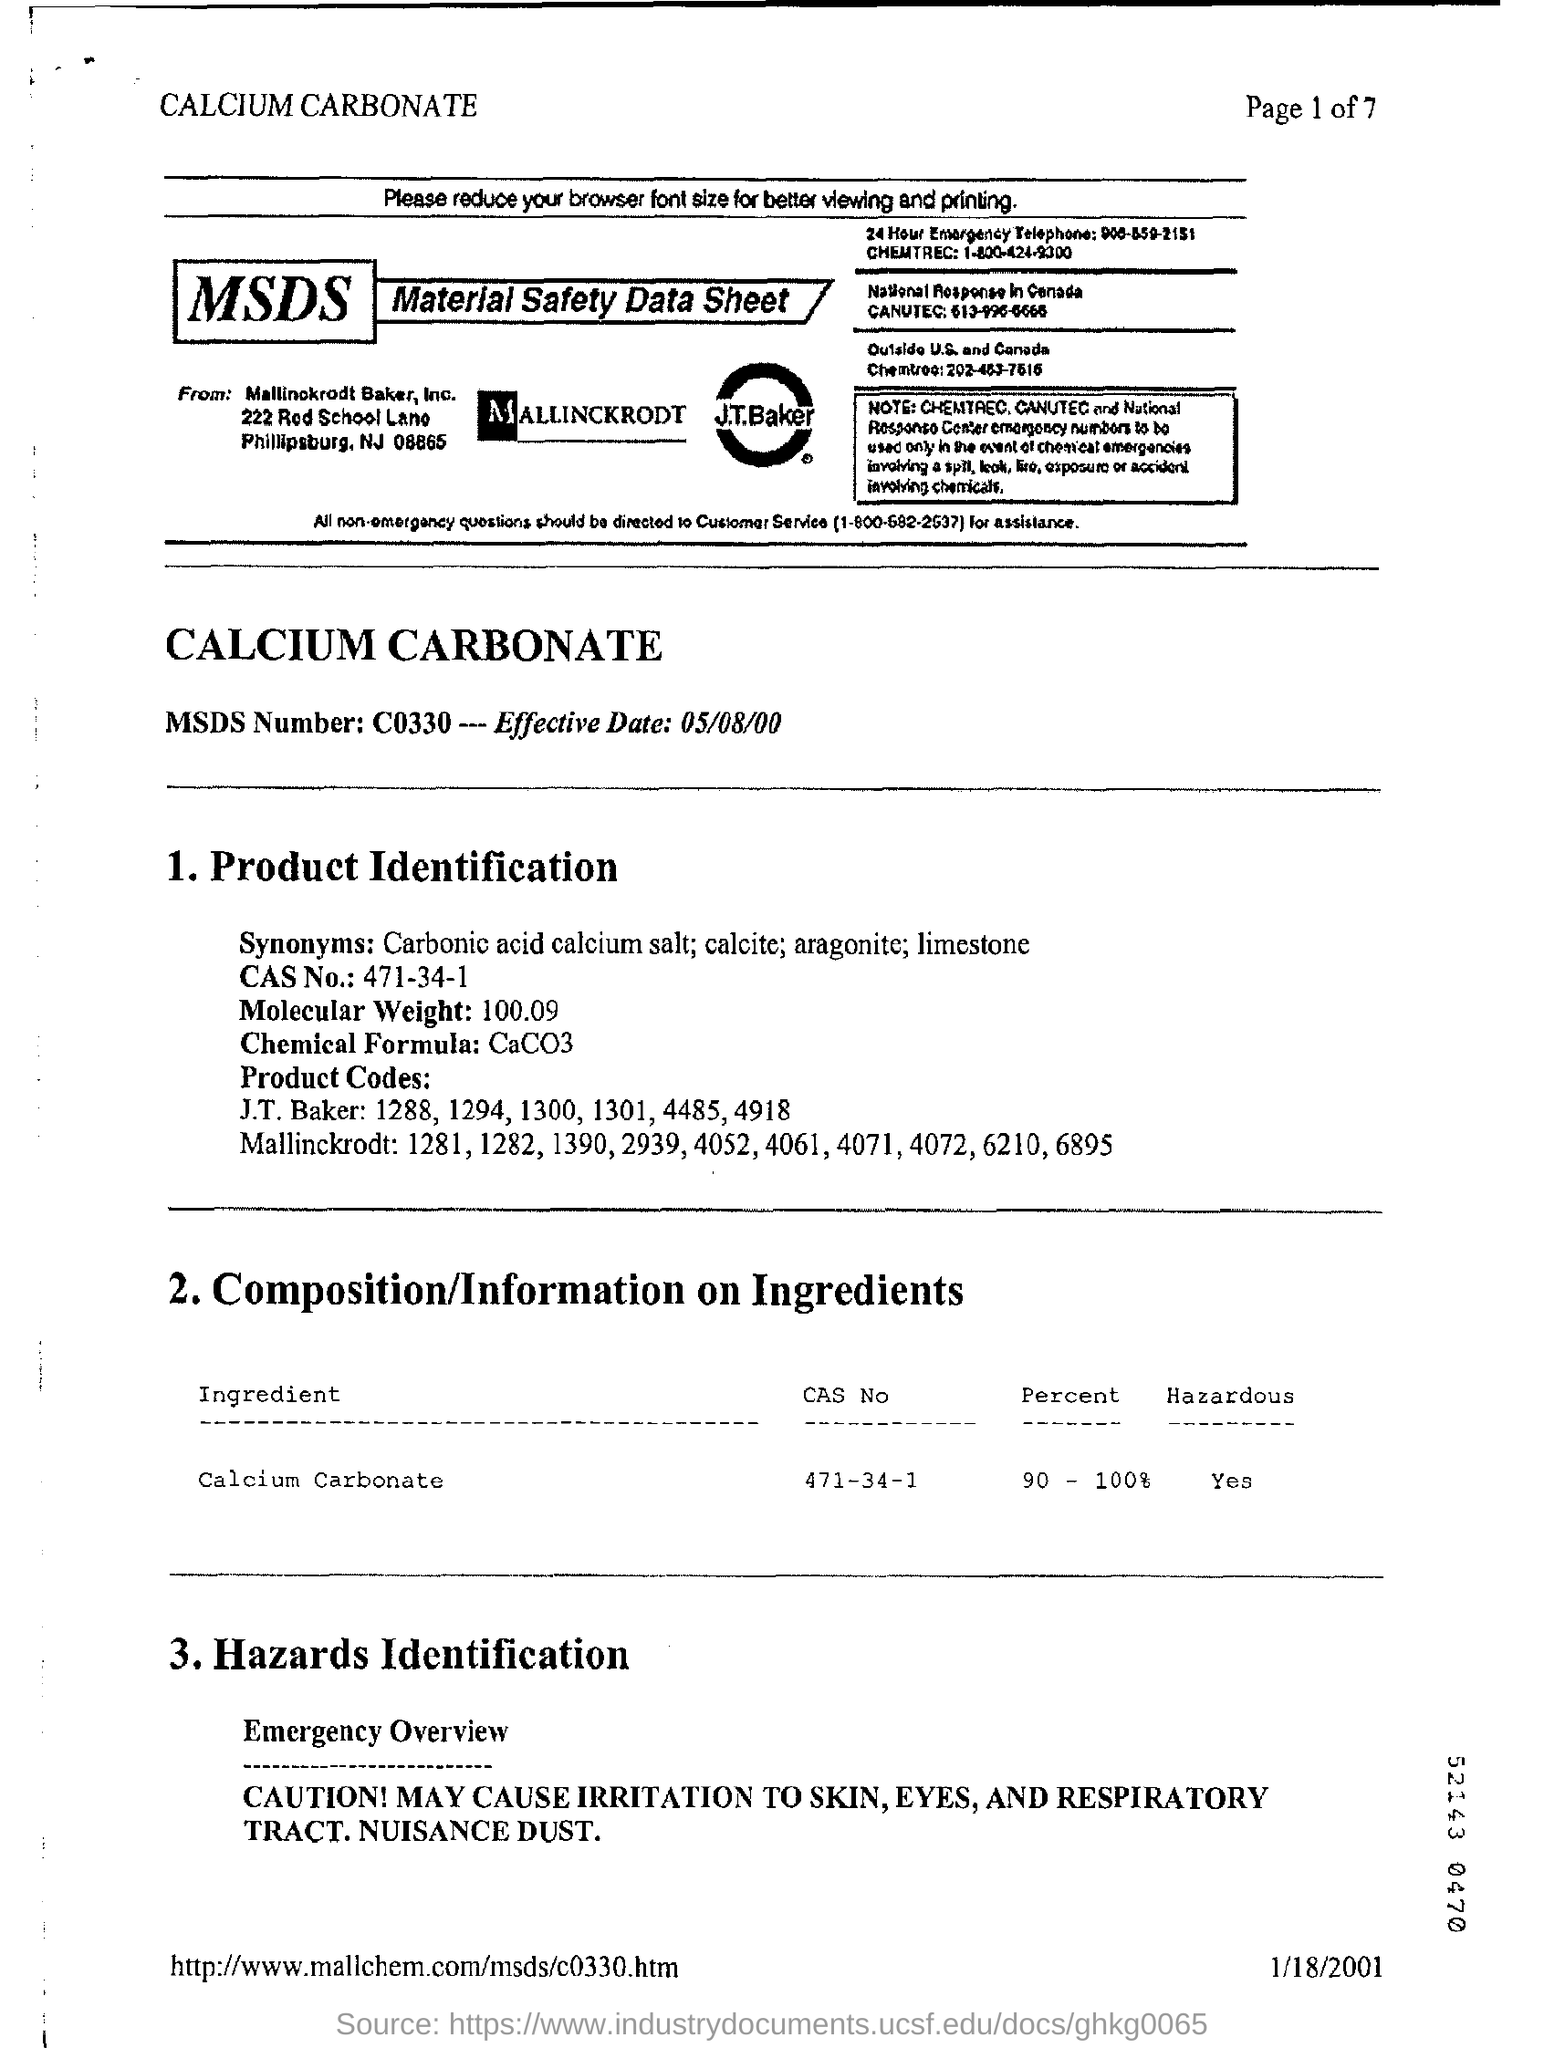Draw attention to some important aspects in this diagram. The molecular weight is 100.09. The chemical compound with a CAS number of 471-34-1 is... The percentage of calcium carbonate is 90 to 100%. As of May 8, 2000, the effective date has been established. The ingredient in question is calcium carbonate, a naturally occurring mineral that is commonly used as an additive in a variety of products, including food and beverages. 